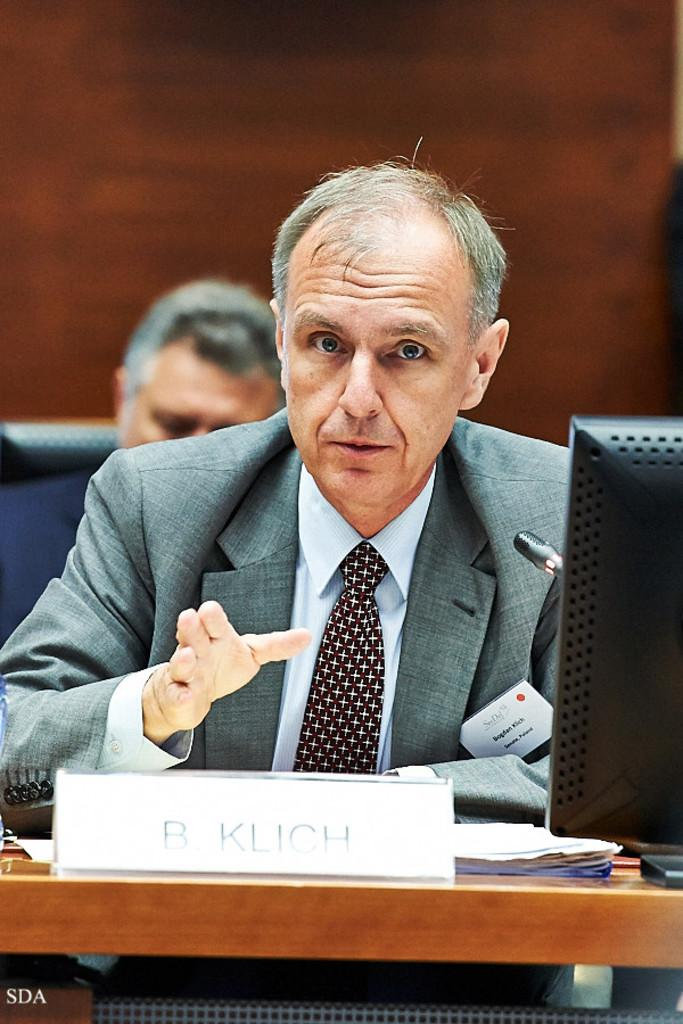What is the person in the image doing? The person is sitting in the image. What is the person wearing? The person is wearing a suit. What object is in front of the person? A computer is present in front of the person. What information can be found on the table? The person's name, B Klich, is written on a piece of paper or object on the table. Can you describe the other person visible in the image? There is another man visible behind the person. What type of lead can be seen in the image? There is no lead present in the image. What is the aftermath of the meeting between the two men in the image? The image does not show the aftermath of a meeting, as it only captures the moment when the person is sitting and the other man is visible behind them. 